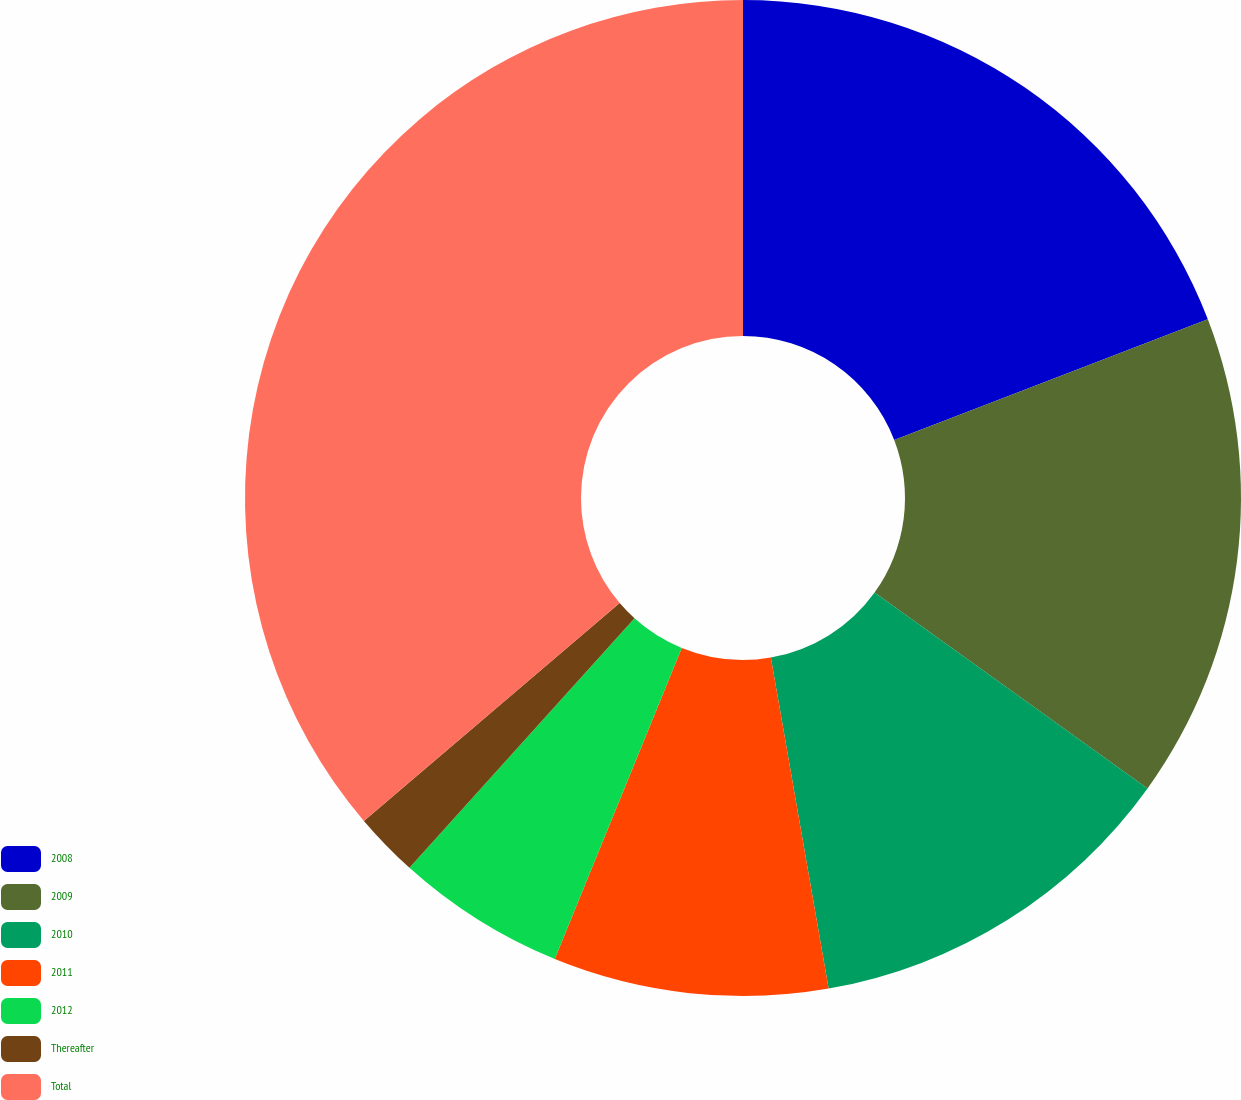Convert chart to OTSL. <chart><loc_0><loc_0><loc_500><loc_500><pie_chart><fcel>2008<fcel>2009<fcel>2010<fcel>2011<fcel>2012<fcel>Thereafter<fcel>Total<nl><fcel>19.16%<fcel>15.75%<fcel>12.34%<fcel>8.92%<fcel>5.51%<fcel>2.09%<fcel>36.23%<nl></chart> 